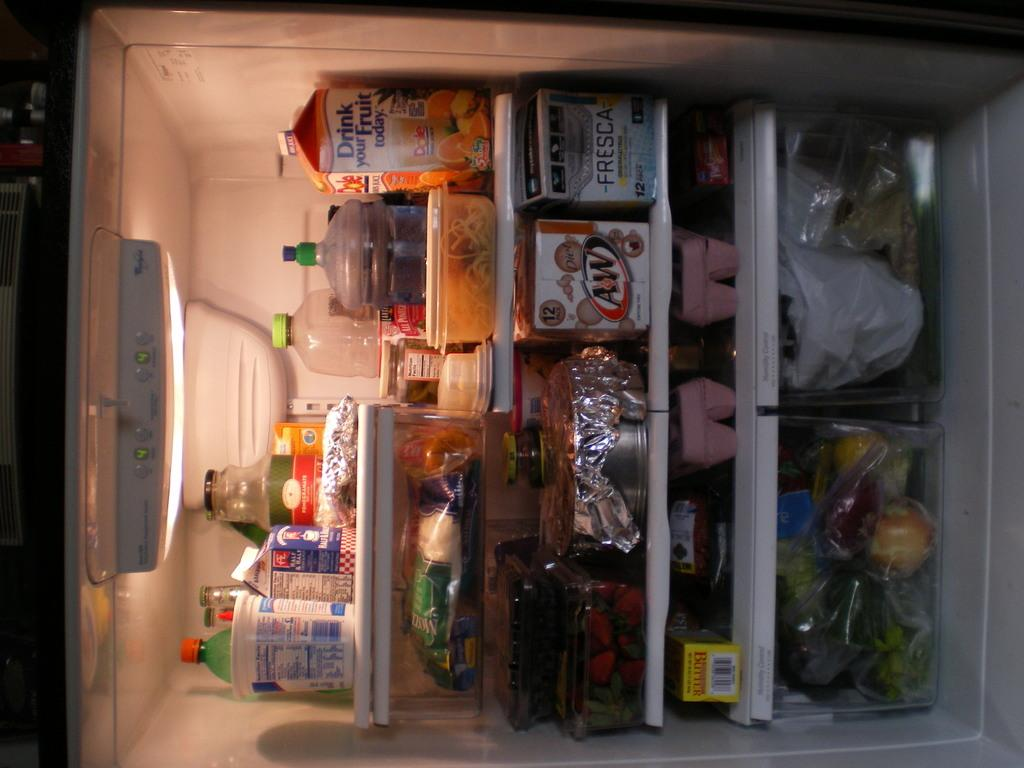<image>
Describe the image concisely. the inside of a fridge with things from AW and Fresca 